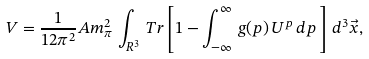<formula> <loc_0><loc_0><loc_500><loc_500>V = \frac { 1 } { 1 2 \pi ^ { 2 } } A m _ { \pi } ^ { 2 } \, \int _ { R ^ { 3 } } \, T r \left [ 1 - \int _ { - \infty } ^ { \infty } \, g ( p ) \, U ^ { p } \, d p \, \right ] \, d ^ { 3 } \vec { x } ,</formula> 